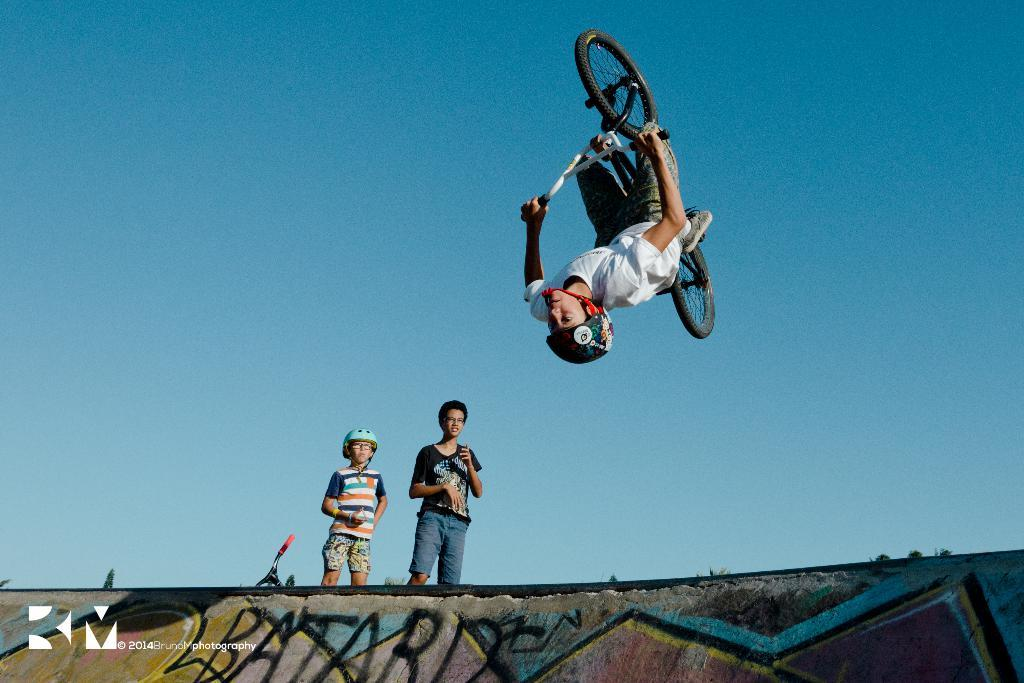What is the main subject of the image? There is a person with a bicycle in the image. Are there any other people visible in the image? Yes, there are two persons standing in the background. What is the color of the sky in the image? The sky is blue in color. What type of profit can be seen in the image? There is no mention of profit in the image; it features a person with a bicycle and two people standing in the background. What type of cooking equipment is visible in the image? There is no cooking equipment visible in the image. 